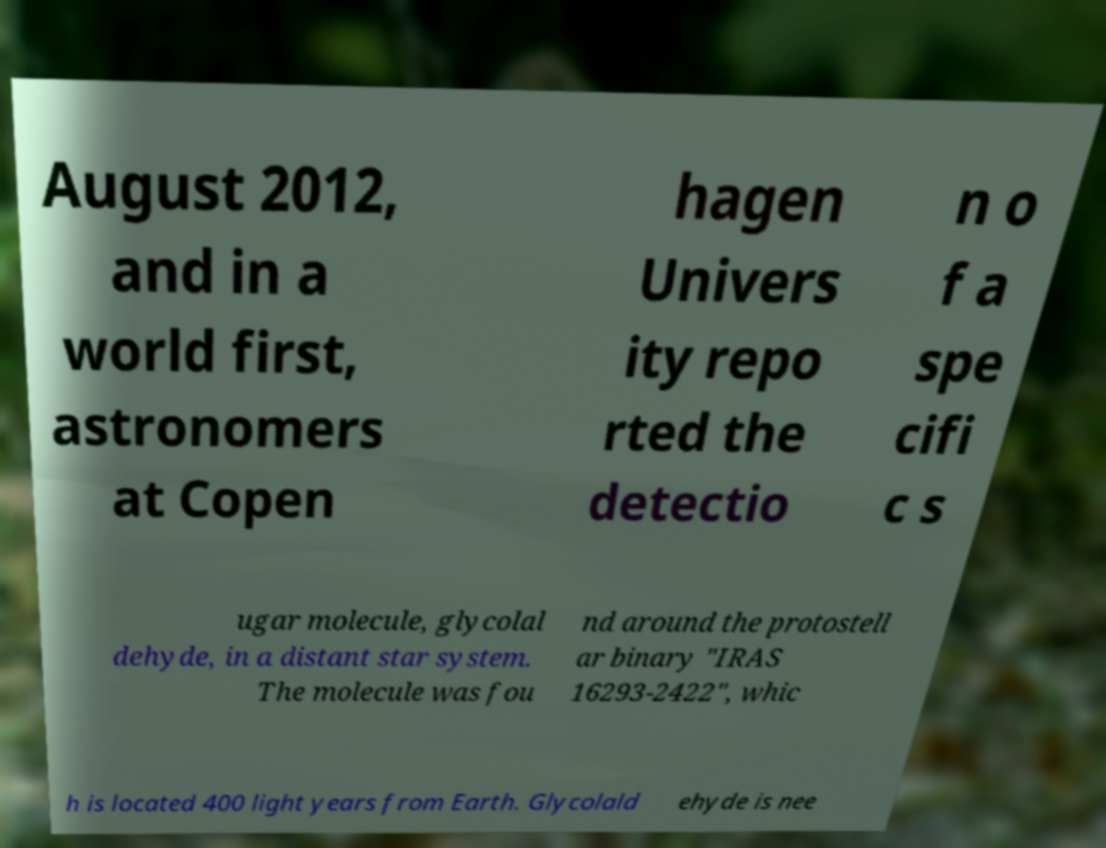What messages or text are displayed in this image? I need them in a readable, typed format. August 2012, and in a world first, astronomers at Copen hagen Univers ity repo rted the detectio n o f a spe cifi c s ugar molecule, glycolal dehyde, in a distant star system. The molecule was fou nd around the protostell ar binary "IRAS 16293-2422", whic h is located 400 light years from Earth. Glycolald ehyde is nee 